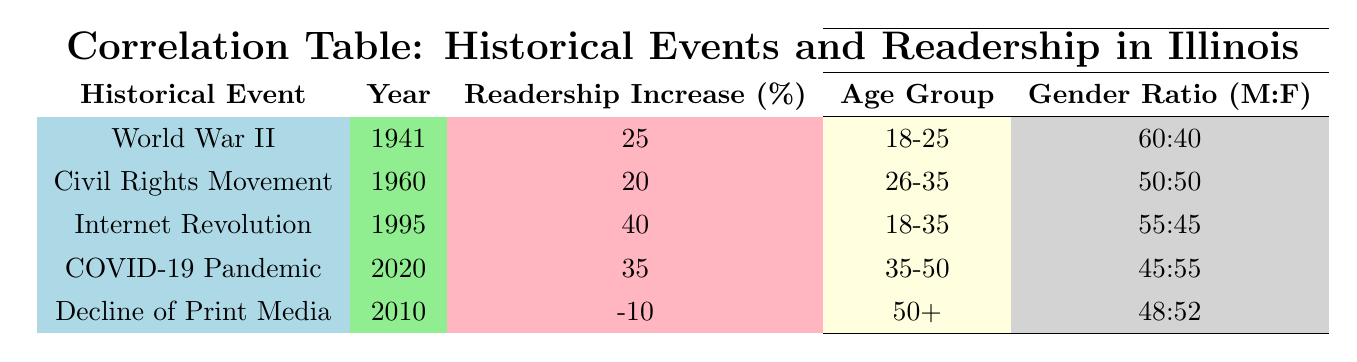What was the highest readership increase percentage recorded in the table? The table shows the readership increase percentages for various historical events. By looking through the percentages, the Internet Revolution has the highest value at 40%.
Answer: 40% Which age group saw a readership increase during the Civil Rights Movement? The demographic change associated with the Civil Rights Movement indicates an increase in readership for the age group 26-35.
Answer: 26-35 Did the readership increase regarding the Decline of Print Media? The table states that the readership increase percentage for the Decline of Print Media is -10%, indicating a decrease in readership. Therefore, the statement is false.
Answer: No What is the gender ratio for the age group 35-50 during the COVID-19 Pandemic? The table indicates that during the COVID-19 Pandemic, the gender ratio for the age group 35-50 is 45:55.
Answer: 45:55 What is the average readership increase percentage from World War II and the Civil Rights Movement? The readership increase percentages for World War II and the Civil Rights Movement are 25% and 20%, respectively. The average is calculated by taking the sum (25 + 20 = 45) and dividing by the number of events (2), resulting in 45/2 = 22.5%.
Answer: 22.5% Which historical event had the greatest demographic increase in the age group 18-35? The Internet Revolution not only resulted in the highest readership increase percentage (40%) but also indicated a demographic increase of 50% in the age group 18-35.
Answer: Internet Revolution Was the readership among males higher than that of females during World War II? The gender ratio for World War II is 60:40, which indicates a higher readership among males compared to females. Therefore, the statement is true.
Answer: Yes What were the demographic changes in terms of the gender ratio for the age group 50+ during the Decline of Print Media? The demographic change for the age group 50+ during the Decline of Print Media shows a gender ratio of 48:52, which indicates a slightly higher percentage of females than males.
Answer: 48:52 How much did the readership increase in the age group 18-25 during World War II? The table indicates that the demographic change for the age group 18-25 during World War II includes a readership increase of 15%.
Answer: 15% 